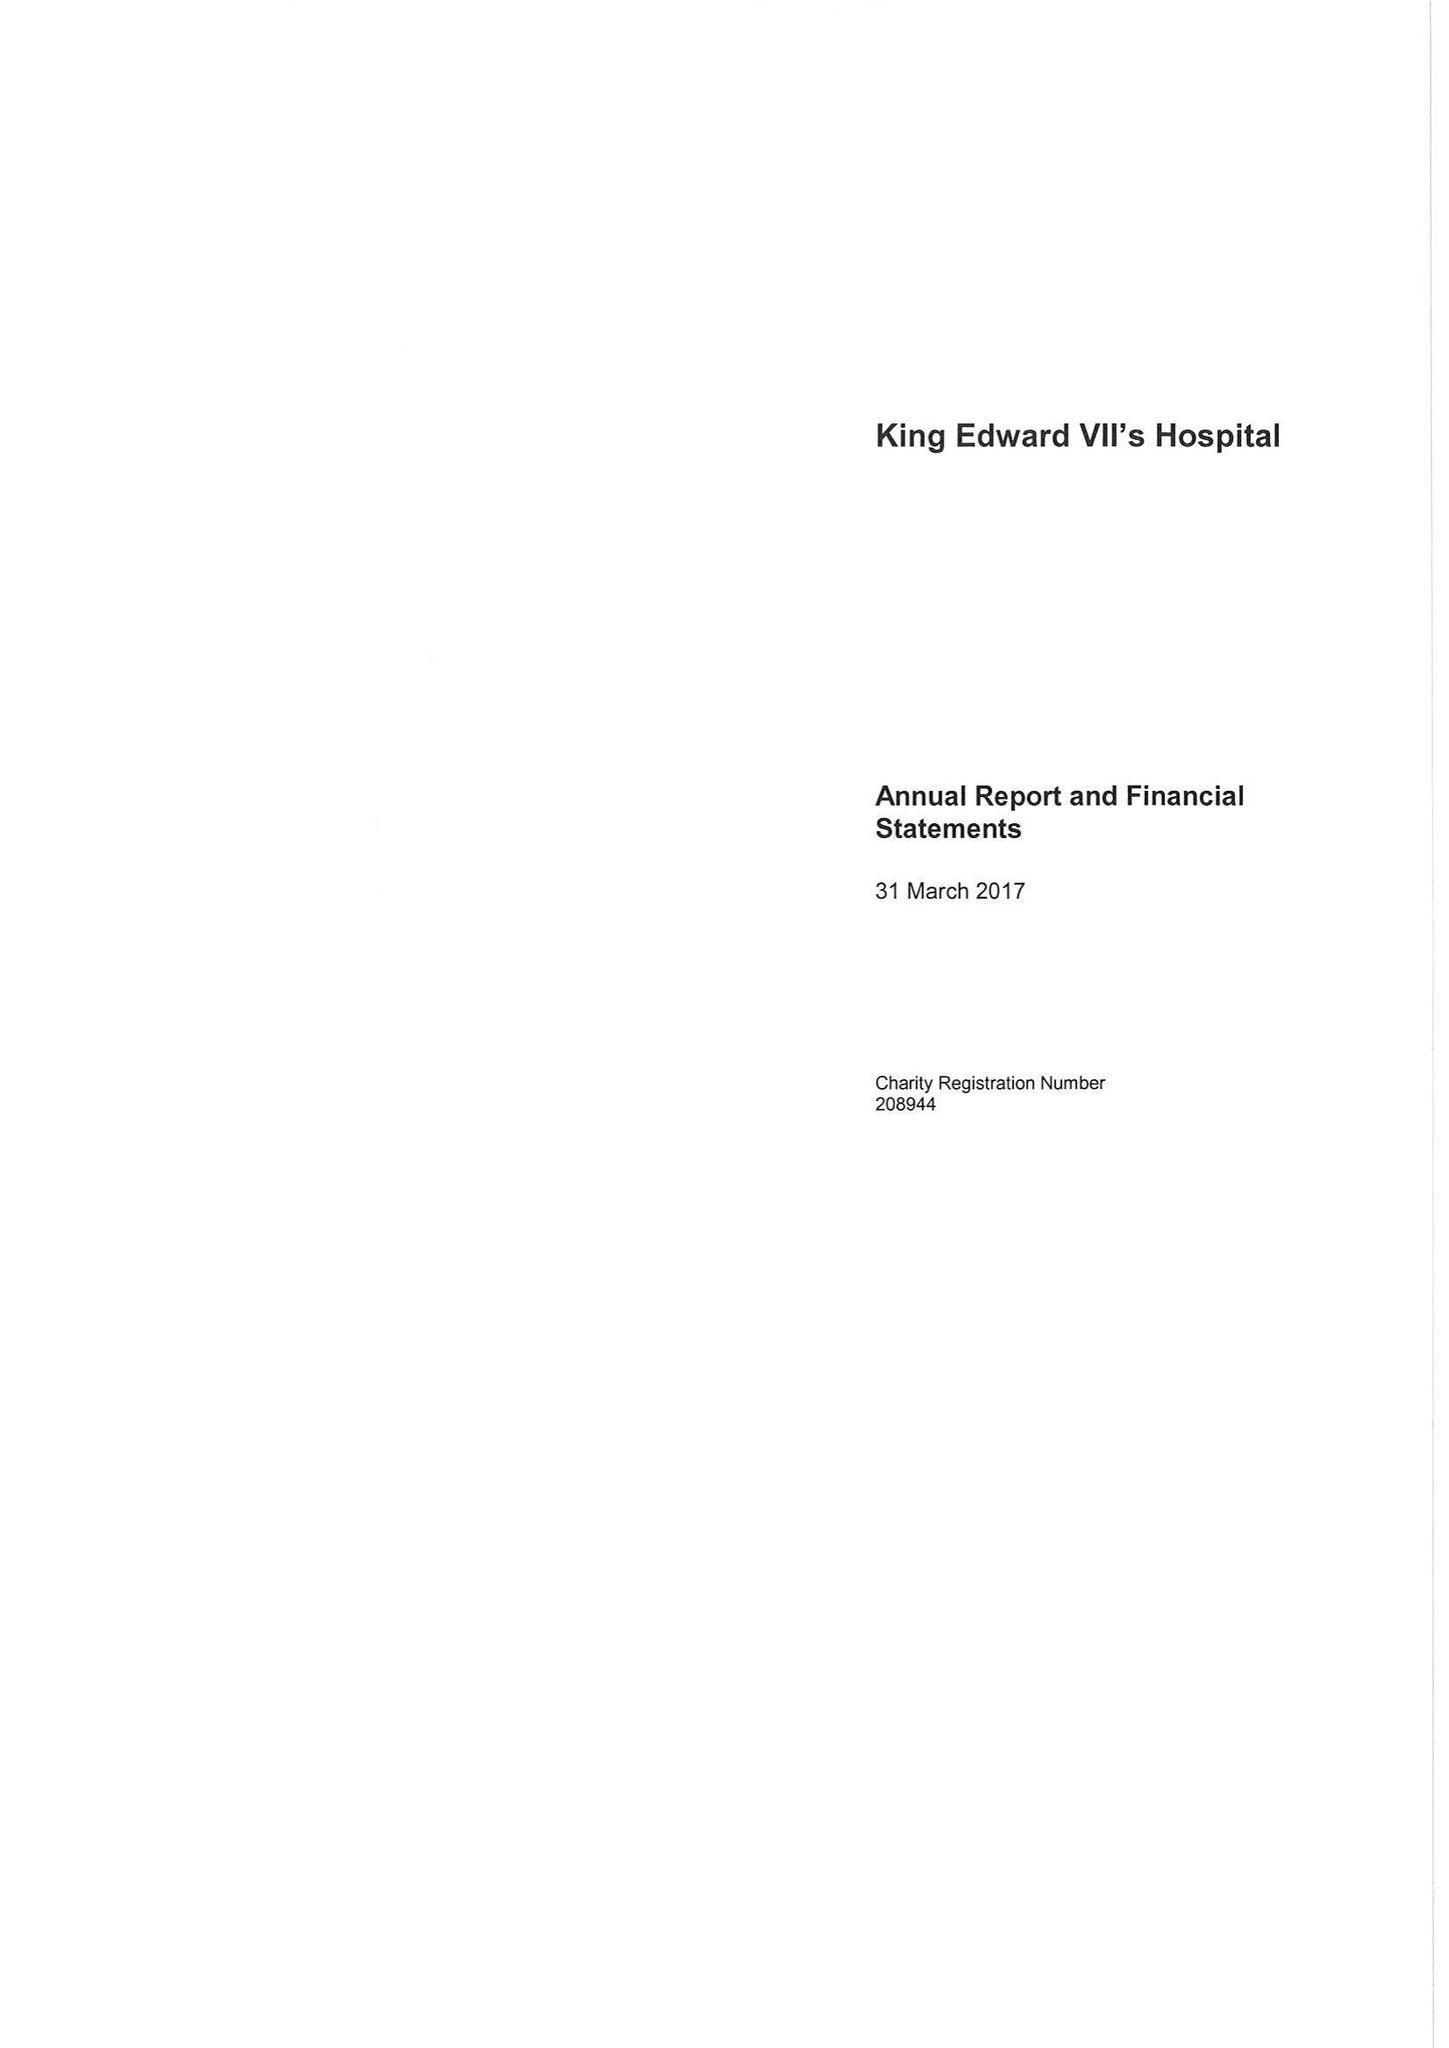What is the value for the income_annually_in_british_pounds?
Answer the question using a single word or phrase. 36436000.00 